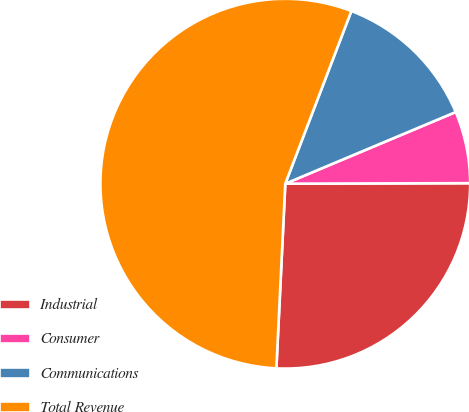Convert chart. <chart><loc_0><loc_0><loc_500><loc_500><pie_chart><fcel>Industrial<fcel>Consumer<fcel>Communications<fcel>Total Revenue<nl><fcel>25.81%<fcel>6.29%<fcel>12.85%<fcel>55.05%<nl></chart> 